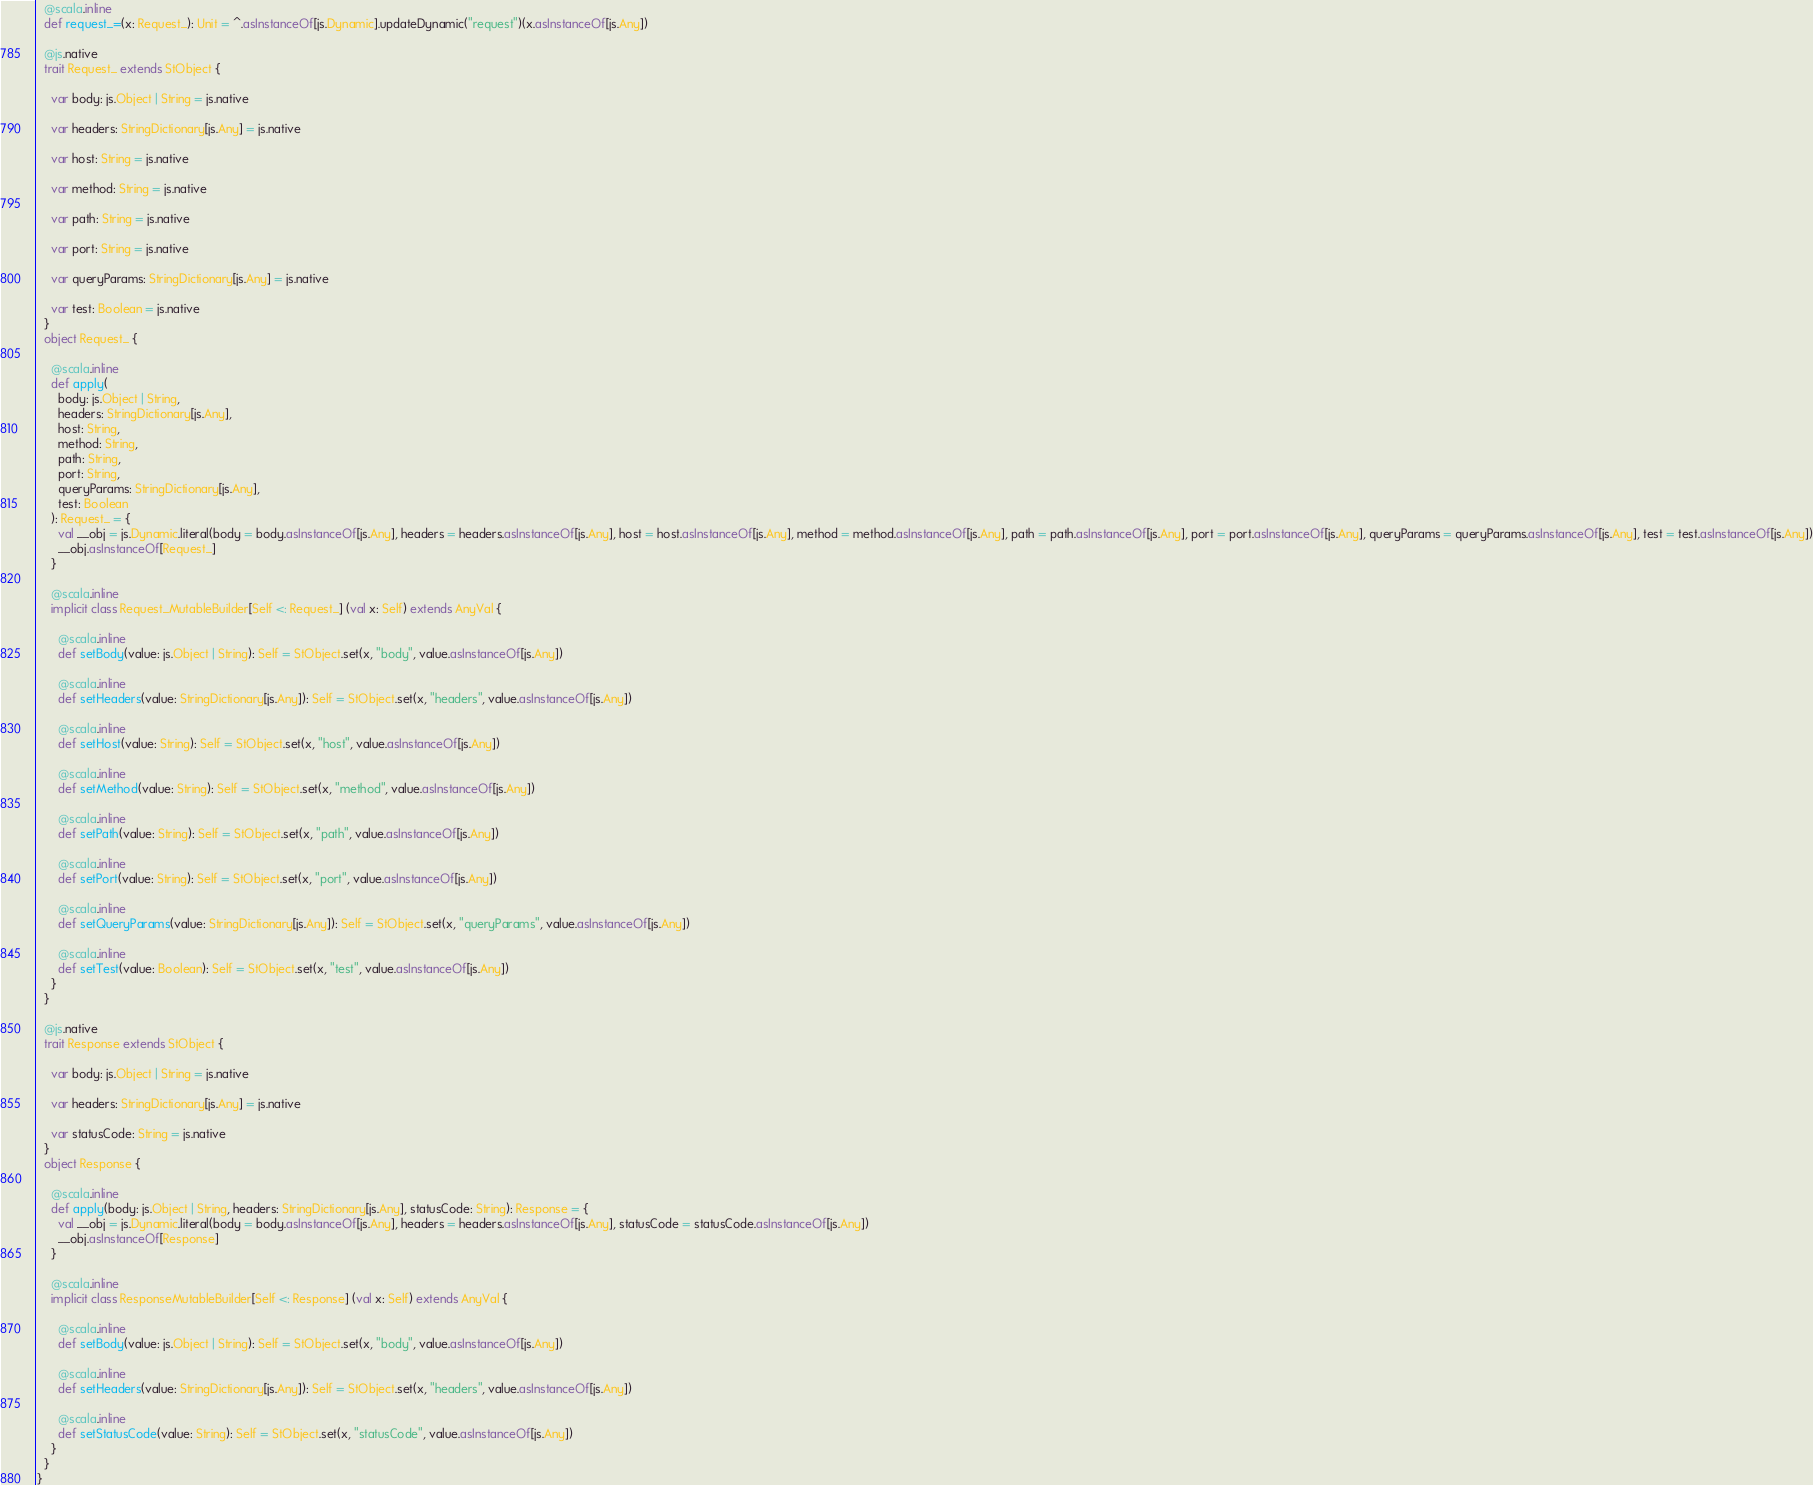Convert code to text. <code><loc_0><loc_0><loc_500><loc_500><_Scala_>  @scala.inline
  def request_=(x: Request_): Unit = ^.asInstanceOf[js.Dynamic].updateDynamic("request")(x.asInstanceOf[js.Any])
  
  @js.native
  trait Request_ extends StObject {
    
    var body: js.Object | String = js.native
    
    var headers: StringDictionary[js.Any] = js.native
    
    var host: String = js.native
    
    var method: String = js.native
    
    var path: String = js.native
    
    var port: String = js.native
    
    var queryParams: StringDictionary[js.Any] = js.native
    
    var test: Boolean = js.native
  }
  object Request_ {
    
    @scala.inline
    def apply(
      body: js.Object | String,
      headers: StringDictionary[js.Any],
      host: String,
      method: String,
      path: String,
      port: String,
      queryParams: StringDictionary[js.Any],
      test: Boolean
    ): Request_ = {
      val __obj = js.Dynamic.literal(body = body.asInstanceOf[js.Any], headers = headers.asInstanceOf[js.Any], host = host.asInstanceOf[js.Any], method = method.asInstanceOf[js.Any], path = path.asInstanceOf[js.Any], port = port.asInstanceOf[js.Any], queryParams = queryParams.asInstanceOf[js.Any], test = test.asInstanceOf[js.Any])
      __obj.asInstanceOf[Request_]
    }
    
    @scala.inline
    implicit class Request_MutableBuilder[Self <: Request_] (val x: Self) extends AnyVal {
      
      @scala.inline
      def setBody(value: js.Object | String): Self = StObject.set(x, "body", value.asInstanceOf[js.Any])
      
      @scala.inline
      def setHeaders(value: StringDictionary[js.Any]): Self = StObject.set(x, "headers", value.asInstanceOf[js.Any])
      
      @scala.inline
      def setHost(value: String): Self = StObject.set(x, "host", value.asInstanceOf[js.Any])
      
      @scala.inline
      def setMethod(value: String): Self = StObject.set(x, "method", value.asInstanceOf[js.Any])
      
      @scala.inline
      def setPath(value: String): Self = StObject.set(x, "path", value.asInstanceOf[js.Any])
      
      @scala.inline
      def setPort(value: String): Self = StObject.set(x, "port", value.asInstanceOf[js.Any])
      
      @scala.inline
      def setQueryParams(value: StringDictionary[js.Any]): Self = StObject.set(x, "queryParams", value.asInstanceOf[js.Any])
      
      @scala.inline
      def setTest(value: Boolean): Self = StObject.set(x, "test", value.asInstanceOf[js.Any])
    }
  }
  
  @js.native
  trait Response extends StObject {
    
    var body: js.Object | String = js.native
    
    var headers: StringDictionary[js.Any] = js.native
    
    var statusCode: String = js.native
  }
  object Response {
    
    @scala.inline
    def apply(body: js.Object | String, headers: StringDictionary[js.Any], statusCode: String): Response = {
      val __obj = js.Dynamic.literal(body = body.asInstanceOf[js.Any], headers = headers.asInstanceOf[js.Any], statusCode = statusCode.asInstanceOf[js.Any])
      __obj.asInstanceOf[Response]
    }
    
    @scala.inline
    implicit class ResponseMutableBuilder[Self <: Response] (val x: Self) extends AnyVal {
      
      @scala.inline
      def setBody(value: js.Object | String): Self = StObject.set(x, "body", value.asInstanceOf[js.Any])
      
      @scala.inline
      def setHeaders(value: StringDictionary[js.Any]): Self = StObject.set(x, "headers", value.asInstanceOf[js.Any])
      
      @scala.inline
      def setStatusCode(value: String): Self = StObject.set(x, "statusCode", value.asInstanceOf[js.Any])
    }
  }
}
</code> 